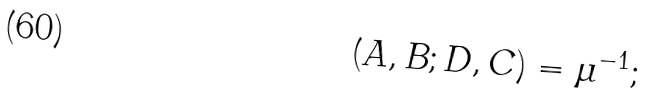<formula> <loc_0><loc_0><loc_500><loc_500>( A , B ; D , C ) = \mu ^ { - 1 } ;</formula> 